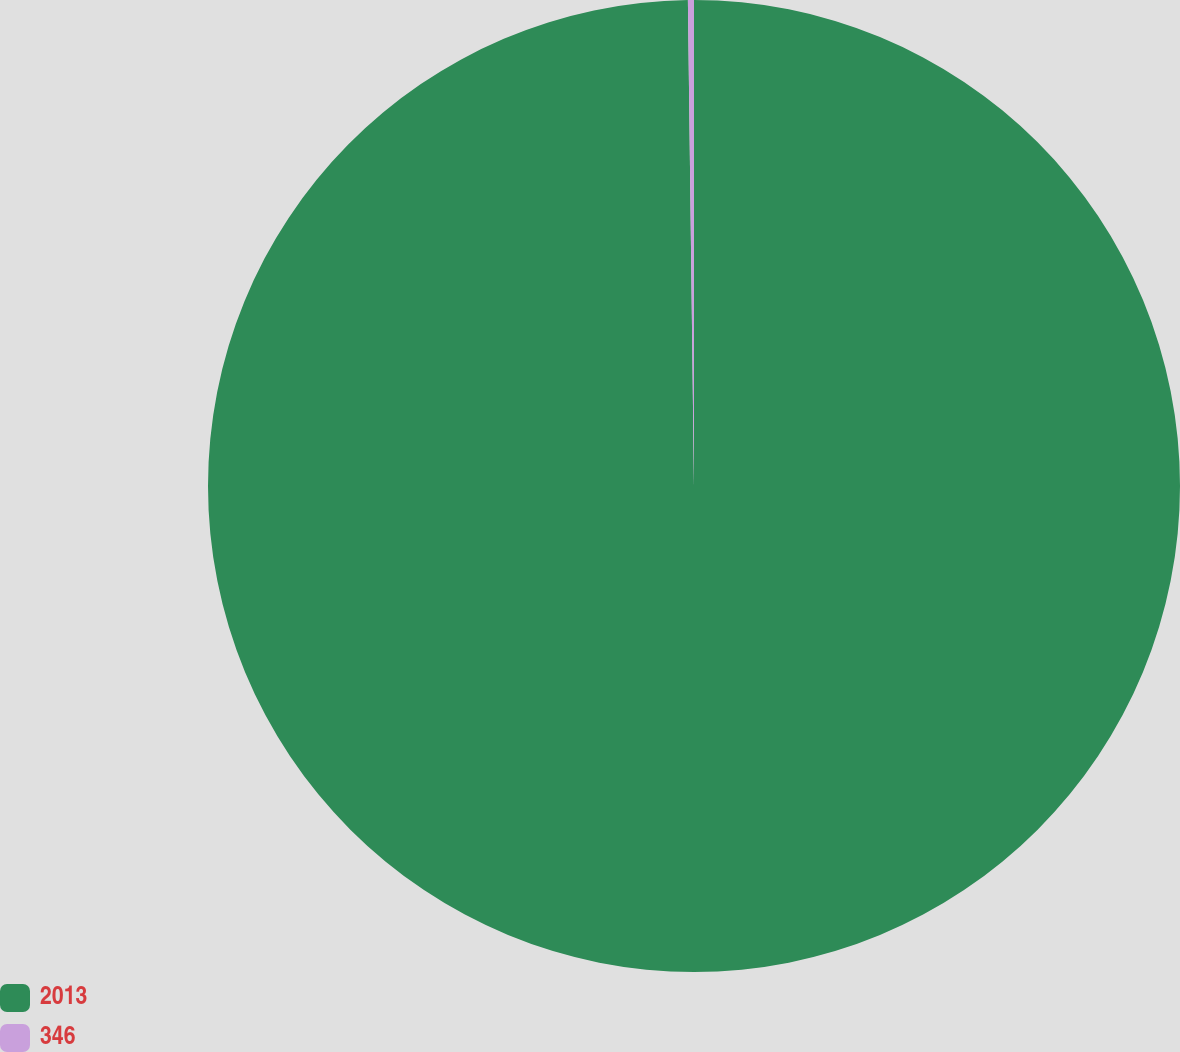Convert chart. <chart><loc_0><loc_0><loc_500><loc_500><pie_chart><fcel>2013<fcel>346<nl><fcel>99.8%<fcel>0.2%<nl></chart> 